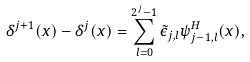Convert formula to latex. <formula><loc_0><loc_0><loc_500><loc_500>\delta ^ { j + 1 } ( x ) - \delta ^ { j } ( x ) = \sum _ { l = 0 } ^ { 2 ^ { j } - 1 } \tilde { \epsilon } _ { j , l } \psi _ { j - 1 , l } ^ { H } ( x ) ,</formula> 